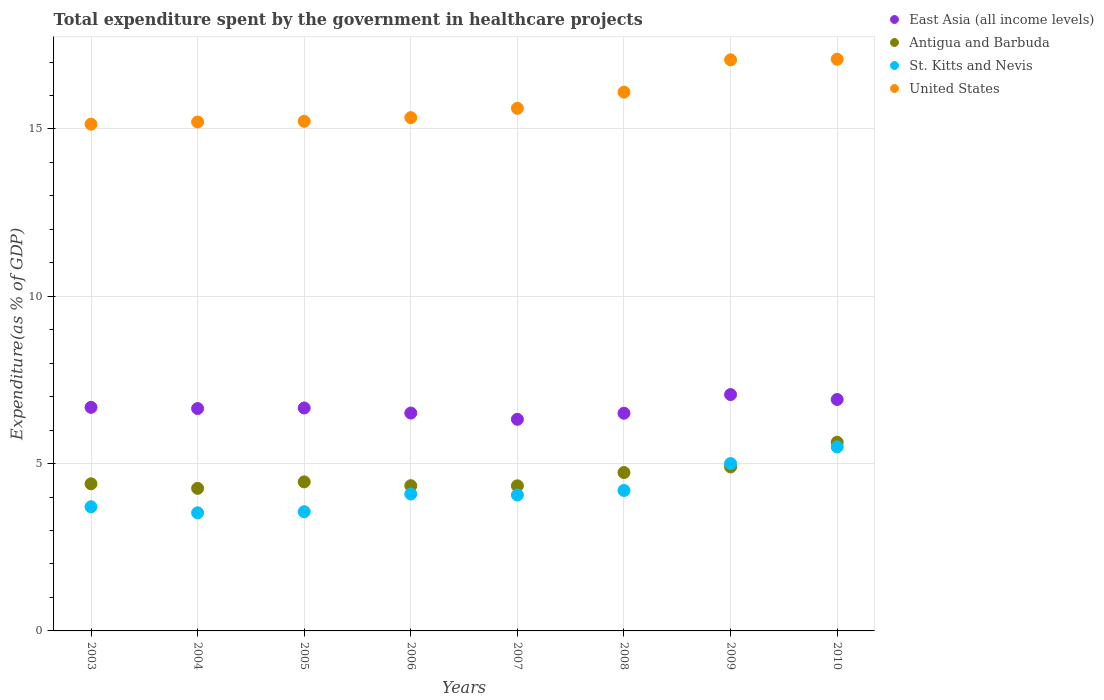How many different coloured dotlines are there?
Your answer should be compact. 4. Is the number of dotlines equal to the number of legend labels?
Give a very brief answer. Yes. What is the total expenditure spent by the government in healthcare projects in St. Kitts and Nevis in 2007?
Your response must be concise. 4.06. Across all years, what is the maximum total expenditure spent by the government in healthcare projects in Antigua and Barbuda?
Your answer should be compact. 5.64. Across all years, what is the minimum total expenditure spent by the government in healthcare projects in Antigua and Barbuda?
Ensure brevity in your answer.  4.26. In which year was the total expenditure spent by the government in healthcare projects in United States maximum?
Keep it short and to the point. 2010. In which year was the total expenditure spent by the government in healthcare projects in United States minimum?
Keep it short and to the point. 2003. What is the total total expenditure spent by the government in healthcare projects in Antigua and Barbuda in the graph?
Ensure brevity in your answer.  37.06. What is the difference between the total expenditure spent by the government in healthcare projects in St. Kitts and Nevis in 2009 and that in 2010?
Give a very brief answer. -0.5. What is the difference between the total expenditure spent by the government in healthcare projects in East Asia (all income levels) in 2003 and the total expenditure spent by the government in healthcare projects in United States in 2007?
Your answer should be compact. -8.94. What is the average total expenditure spent by the government in healthcare projects in Antigua and Barbuda per year?
Your response must be concise. 4.63. In the year 2010, what is the difference between the total expenditure spent by the government in healthcare projects in East Asia (all income levels) and total expenditure spent by the government in healthcare projects in St. Kitts and Nevis?
Ensure brevity in your answer.  1.42. In how many years, is the total expenditure spent by the government in healthcare projects in Antigua and Barbuda greater than 16 %?
Keep it short and to the point. 0. What is the ratio of the total expenditure spent by the government in healthcare projects in Antigua and Barbuda in 2004 to that in 2008?
Ensure brevity in your answer.  0.9. Is the total expenditure spent by the government in healthcare projects in St. Kitts and Nevis in 2003 less than that in 2010?
Your answer should be compact. Yes. What is the difference between the highest and the second highest total expenditure spent by the government in healthcare projects in St. Kitts and Nevis?
Make the answer very short. 0.5. What is the difference between the highest and the lowest total expenditure spent by the government in healthcare projects in St. Kitts and Nevis?
Provide a succinct answer. 1.97. Is the total expenditure spent by the government in healthcare projects in Antigua and Barbuda strictly greater than the total expenditure spent by the government in healthcare projects in United States over the years?
Your answer should be very brief. No. How many dotlines are there?
Your answer should be compact. 4. Are the values on the major ticks of Y-axis written in scientific E-notation?
Your response must be concise. No. How many legend labels are there?
Your answer should be very brief. 4. How are the legend labels stacked?
Offer a very short reply. Vertical. What is the title of the graph?
Offer a terse response. Total expenditure spent by the government in healthcare projects. What is the label or title of the X-axis?
Ensure brevity in your answer.  Years. What is the label or title of the Y-axis?
Your response must be concise. Expenditure(as % of GDP). What is the Expenditure(as % of GDP) of East Asia (all income levels) in 2003?
Keep it short and to the point. 6.68. What is the Expenditure(as % of GDP) of Antigua and Barbuda in 2003?
Provide a succinct answer. 4.4. What is the Expenditure(as % of GDP) in St. Kitts and Nevis in 2003?
Provide a short and direct response. 3.71. What is the Expenditure(as % of GDP) in United States in 2003?
Your answer should be compact. 15.14. What is the Expenditure(as % of GDP) in East Asia (all income levels) in 2004?
Your answer should be very brief. 6.65. What is the Expenditure(as % of GDP) of Antigua and Barbuda in 2004?
Offer a very short reply. 4.26. What is the Expenditure(as % of GDP) in St. Kitts and Nevis in 2004?
Offer a very short reply. 3.53. What is the Expenditure(as % of GDP) in United States in 2004?
Keep it short and to the point. 15.21. What is the Expenditure(as % of GDP) in East Asia (all income levels) in 2005?
Your response must be concise. 6.66. What is the Expenditure(as % of GDP) of Antigua and Barbuda in 2005?
Your answer should be compact. 4.45. What is the Expenditure(as % of GDP) of St. Kitts and Nevis in 2005?
Provide a short and direct response. 3.56. What is the Expenditure(as % of GDP) of United States in 2005?
Give a very brief answer. 15.23. What is the Expenditure(as % of GDP) in East Asia (all income levels) in 2006?
Offer a terse response. 6.51. What is the Expenditure(as % of GDP) of Antigua and Barbuda in 2006?
Offer a very short reply. 4.34. What is the Expenditure(as % of GDP) in St. Kitts and Nevis in 2006?
Ensure brevity in your answer.  4.09. What is the Expenditure(as % of GDP) of United States in 2006?
Make the answer very short. 15.34. What is the Expenditure(as % of GDP) of East Asia (all income levels) in 2007?
Make the answer very short. 6.32. What is the Expenditure(as % of GDP) in Antigua and Barbuda in 2007?
Give a very brief answer. 4.34. What is the Expenditure(as % of GDP) in St. Kitts and Nevis in 2007?
Give a very brief answer. 4.06. What is the Expenditure(as % of GDP) in United States in 2007?
Offer a terse response. 15.62. What is the Expenditure(as % of GDP) in East Asia (all income levels) in 2008?
Provide a succinct answer. 6.51. What is the Expenditure(as % of GDP) in Antigua and Barbuda in 2008?
Make the answer very short. 4.73. What is the Expenditure(as % of GDP) of St. Kitts and Nevis in 2008?
Your answer should be very brief. 4.2. What is the Expenditure(as % of GDP) of United States in 2008?
Keep it short and to the point. 16.1. What is the Expenditure(as % of GDP) in East Asia (all income levels) in 2009?
Make the answer very short. 7.06. What is the Expenditure(as % of GDP) of Antigua and Barbuda in 2009?
Keep it short and to the point. 4.9. What is the Expenditure(as % of GDP) of St. Kitts and Nevis in 2009?
Provide a short and direct response. 5. What is the Expenditure(as % of GDP) of United States in 2009?
Give a very brief answer. 17.07. What is the Expenditure(as % of GDP) in East Asia (all income levels) in 2010?
Your answer should be very brief. 6.92. What is the Expenditure(as % of GDP) in Antigua and Barbuda in 2010?
Offer a very short reply. 5.64. What is the Expenditure(as % of GDP) in St. Kitts and Nevis in 2010?
Provide a short and direct response. 5.5. What is the Expenditure(as % of GDP) of United States in 2010?
Make the answer very short. 17.08. Across all years, what is the maximum Expenditure(as % of GDP) in East Asia (all income levels)?
Provide a short and direct response. 7.06. Across all years, what is the maximum Expenditure(as % of GDP) in Antigua and Barbuda?
Keep it short and to the point. 5.64. Across all years, what is the maximum Expenditure(as % of GDP) in St. Kitts and Nevis?
Ensure brevity in your answer.  5.5. Across all years, what is the maximum Expenditure(as % of GDP) in United States?
Your answer should be compact. 17.08. Across all years, what is the minimum Expenditure(as % of GDP) of East Asia (all income levels)?
Offer a very short reply. 6.32. Across all years, what is the minimum Expenditure(as % of GDP) of Antigua and Barbuda?
Your response must be concise. 4.26. Across all years, what is the minimum Expenditure(as % of GDP) in St. Kitts and Nevis?
Provide a succinct answer. 3.53. Across all years, what is the minimum Expenditure(as % of GDP) in United States?
Your answer should be compact. 15.14. What is the total Expenditure(as % of GDP) in East Asia (all income levels) in the graph?
Offer a terse response. 53.31. What is the total Expenditure(as % of GDP) in Antigua and Barbuda in the graph?
Keep it short and to the point. 37.06. What is the total Expenditure(as % of GDP) of St. Kitts and Nevis in the graph?
Offer a terse response. 33.66. What is the total Expenditure(as % of GDP) of United States in the graph?
Give a very brief answer. 126.79. What is the difference between the Expenditure(as % of GDP) of East Asia (all income levels) in 2003 and that in 2004?
Offer a terse response. 0.04. What is the difference between the Expenditure(as % of GDP) in Antigua and Barbuda in 2003 and that in 2004?
Keep it short and to the point. 0.14. What is the difference between the Expenditure(as % of GDP) in St. Kitts and Nevis in 2003 and that in 2004?
Offer a terse response. 0.18. What is the difference between the Expenditure(as % of GDP) in United States in 2003 and that in 2004?
Your answer should be compact. -0.06. What is the difference between the Expenditure(as % of GDP) in East Asia (all income levels) in 2003 and that in 2005?
Give a very brief answer. 0.02. What is the difference between the Expenditure(as % of GDP) of Antigua and Barbuda in 2003 and that in 2005?
Your answer should be very brief. -0.06. What is the difference between the Expenditure(as % of GDP) in St. Kitts and Nevis in 2003 and that in 2005?
Your response must be concise. 0.15. What is the difference between the Expenditure(as % of GDP) of United States in 2003 and that in 2005?
Offer a terse response. -0.09. What is the difference between the Expenditure(as % of GDP) in East Asia (all income levels) in 2003 and that in 2006?
Your answer should be compact. 0.17. What is the difference between the Expenditure(as % of GDP) in Antigua and Barbuda in 2003 and that in 2006?
Your answer should be compact. 0.06. What is the difference between the Expenditure(as % of GDP) in St. Kitts and Nevis in 2003 and that in 2006?
Ensure brevity in your answer.  -0.38. What is the difference between the Expenditure(as % of GDP) of United States in 2003 and that in 2006?
Offer a very short reply. -0.19. What is the difference between the Expenditure(as % of GDP) in East Asia (all income levels) in 2003 and that in 2007?
Offer a terse response. 0.36. What is the difference between the Expenditure(as % of GDP) of Antigua and Barbuda in 2003 and that in 2007?
Give a very brief answer. 0.06. What is the difference between the Expenditure(as % of GDP) in St. Kitts and Nevis in 2003 and that in 2007?
Offer a very short reply. -0.35. What is the difference between the Expenditure(as % of GDP) in United States in 2003 and that in 2007?
Your answer should be compact. -0.47. What is the difference between the Expenditure(as % of GDP) in East Asia (all income levels) in 2003 and that in 2008?
Your answer should be compact. 0.18. What is the difference between the Expenditure(as % of GDP) of Antigua and Barbuda in 2003 and that in 2008?
Provide a succinct answer. -0.34. What is the difference between the Expenditure(as % of GDP) in St. Kitts and Nevis in 2003 and that in 2008?
Offer a terse response. -0.49. What is the difference between the Expenditure(as % of GDP) of United States in 2003 and that in 2008?
Make the answer very short. -0.96. What is the difference between the Expenditure(as % of GDP) in East Asia (all income levels) in 2003 and that in 2009?
Keep it short and to the point. -0.38. What is the difference between the Expenditure(as % of GDP) of Antigua and Barbuda in 2003 and that in 2009?
Offer a very short reply. -0.5. What is the difference between the Expenditure(as % of GDP) of St. Kitts and Nevis in 2003 and that in 2009?
Give a very brief answer. -1.29. What is the difference between the Expenditure(as % of GDP) of United States in 2003 and that in 2009?
Offer a very short reply. -1.92. What is the difference between the Expenditure(as % of GDP) of East Asia (all income levels) in 2003 and that in 2010?
Offer a terse response. -0.24. What is the difference between the Expenditure(as % of GDP) of Antigua and Barbuda in 2003 and that in 2010?
Provide a succinct answer. -1.24. What is the difference between the Expenditure(as % of GDP) of St. Kitts and Nevis in 2003 and that in 2010?
Offer a terse response. -1.79. What is the difference between the Expenditure(as % of GDP) of United States in 2003 and that in 2010?
Keep it short and to the point. -1.94. What is the difference between the Expenditure(as % of GDP) in East Asia (all income levels) in 2004 and that in 2005?
Your response must be concise. -0.02. What is the difference between the Expenditure(as % of GDP) of Antigua and Barbuda in 2004 and that in 2005?
Give a very brief answer. -0.19. What is the difference between the Expenditure(as % of GDP) of St. Kitts and Nevis in 2004 and that in 2005?
Keep it short and to the point. -0.03. What is the difference between the Expenditure(as % of GDP) in United States in 2004 and that in 2005?
Give a very brief answer. -0.02. What is the difference between the Expenditure(as % of GDP) in East Asia (all income levels) in 2004 and that in 2006?
Offer a terse response. 0.14. What is the difference between the Expenditure(as % of GDP) of Antigua and Barbuda in 2004 and that in 2006?
Your response must be concise. -0.08. What is the difference between the Expenditure(as % of GDP) of St. Kitts and Nevis in 2004 and that in 2006?
Provide a succinct answer. -0.56. What is the difference between the Expenditure(as % of GDP) of United States in 2004 and that in 2006?
Keep it short and to the point. -0.13. What is the difference between the Expenditure(as % of GDP) of East Asia (all income levels) in 2004 and that in 2007?
Your answer should be very brief. 0.32. What is the difference between the Expenditure(as % of GDP) in Antigua and Barbuda in 2004 and that in 2007?
Offer a terse response. -0.08. What is the difference between the Expenditure(as % of GDP) of St. Kitts and Nevis in 2004 and that in 2007?
Provide a short and direct response. -0.53. What is the difference between the Expenditure(as % of GDP) of United States in 2004 and that in 2007?
Ensure brevity in your answer.  -0.41. What is the difference between the Expenditure(as % of GDP) of East Asia (all income levels) in 2004 and that in 2008?
Give a very brief answer. 0.14. What is the difference between the Expenditure(as % of GDP) of Antigua and Barbuda in 2004 and that in 2008?
Keep it short and to the point. -0.47. What is the difference between the Expenditure(as % of GDP) in St. Kitts and Nevis in 2004 and that in 2008?
Your answer should be very brief. -0.67. What is the difference between the Expenditure(as % of GDP) in United States in 2004 and that in 2008?
Your answer should be compact. -0.89. What is the difference between the Expenditure(as % of GDP) in East Asia (all income levels) in 2004 and that in 2009?
Give a very brief answer. -0.42. What is the difference between the Expenditure(as % of GDP) in Antigua and Barbuda in 2004 and that in 2009?
Ensure brevity in your answer.  -0.64. What is the difference between the Expenditure(as % of GDP) of St. Kitts and Nevis in 2004 and that in 2009?
Offer a very short reply. -1.47. What is the difference between the Expenditure(as % of GDP) of United States in 2004 and that in 2009?
Your response must be concise. -1.86. What is the difference between the Expenditure(as % of GDP) of East Asia (all income levels) in 2004 and that in 2010?
Ensure brevity in your answer.  -0.27. What is the difference between the Expenditure(as % of GDP) of Antigua and Barbuda in 2004 and that in 2010?
Keep it short and to the point. -1.38. What is the difference between the Expenditure(as % of GDP) of St. Kitts and Nevis in 2004 and that in 2010?
Provide a succinct answer. -1.97. What is the difference between the Expenditure(as % of GDP) of United States in 2004 and that in 2010?
Offer a terse response. -1.87. What is the difference between the Expenditure(as % of GDP) of East Asia (all income levels) in 2005 and that in 2006?
Your answer should be compact. 0.15. What is the difference between the Expenditure(as % of GDP) in Antigua and Barbuda in 2005 and that in 2006?
Offer a terse response. 0.11. What is the difference between the Expenditure(as % of GDP) in St. Kitts and Nevis in 2005 and that in 2006?
Make the answer very short. -0.53. What is the difference between the Expenditure(as % of GDP) of United States in 2005 and that in 2006?
Give a very brief answer. -0.11. What is the difference between the Expenditure(as % of GDP) of East Asia (all income levels) in 2005 and that in 2007?
Offer a terse response. 0.34. What is the difference between the Expenditure(as % of GDP) of Antigua and Barbuda in 2005 and that in 2007?
Offer a terse response. 0.12. What is the difference between the Expenditure(as % of GDP) in St. Kitts and Nevis in 2005 and that in 2007?
Your answer should be very brief. -0.5. What is the difference between the Expenditure(as % of GDP) in United States in 2005 and that in 2007?
Offer a very short reply. -0.39. What is the difference between the Expenditure(as % of GDP) in East Asia (all income levels) in 2005 and that in 2008?
Offer a terse response. 0.16. What is the difference between the Expenditure(as % of GDP) of Antigua and Barbuda in 2005 and that in 2008?
Provide a short and direct response. -0.28. What is the difference between the Expenditure(as % of GDP) in St. Kitts and Nevis in 2005 and that in 2008?
Offer a very short reply. -0.64. What is the difference between the Expenditure(as % of GDP) in United States in 2005 and that in 2008?
Your answer should be compact. -0.87. What is the difference between the Expenditure(as % of GDP) of East Asia (all income levels) in 2005 and that in 2009?
Your answer should be compact. -0.4. What is the difference between the Expenditure(as % of GDP) in Antigua and Barbuda in 2005 and that in 2009?
Provide a succinct answer. -0.45. What is the difference between the Expenditure(as % of GDP) of St. Kitts and Nevis in 2005 and that in 2009?
Give a very brief answer. -1.44. What is the difference between the Expenditure(as % of GDP) in United States in 2005 and that in 2009?
Offer a terse response. -1.84. What is the difference between the Expenditure(as % of GDP) of East Asia (all income levels) in 2005 and that in 2010?
Provide a succinct answer. -0.25. What is the difference between the Expenditure(as % of GDP) in Antigua and Barbuda in 2005 and that in 2010?
Ensure brevity in your answer.  -1.18. What is the difference between the Expenditure(as % of GDP) of St. Kitts and Nevis in 2005 and that in 2010?
Give a very brief answer. -1.94. What is the difference between the Expenditure(as % of GDP) of United States in 2005 and that in 2010?
Keep it short and to the point. -1.85. What is the difference between the Expenditure(as % of GDP) in East Asia (all income levels) in 2006 and that in 2007?
Ensure brevity in your answer.  0.19. What is the difference between the Expenditure(as % of GDP) of Antigua and Barbuda in 2006 and that in 2007?
Make the answer very short. 0. What is the difference between the Expenditure(as % of GDP) of St. Kitts and Nevis in 2006 and that in 2007?
Your response must be concise. 0.03. What is the difference between the Expenditure(as % of GDP) in United States in 2006 and that in 2007?
Provide a short and direct response. -0.28. What is the difference between the Expenditure(as % of GDP) in East Asia (all income levels) in 2006 and that in 2008?
Provide a succinct answer. 0.01. What is the difference between the Expenditure(as % of GDP) of Antigua and Barbuda in 2006 and that in 2008?
Keep it short and to the point. -0.39. What is the difference between the Expenditure(as % of GDP) of St. Kitts and Nevis in 2006 and that in 2008?
Your answer should be very brief. -0.11. What is the difference between the Expenditure(as % of GDP) of United States in 2006 and that in 2008?
Give a very brief answer. -0.76. What is the difference between the Expenditure(as % of GDP) of East Asia (all income levels) in 2006 and that in 2009?
Your answer should be very brief. -0.55. What is the difference between the Expenditure(as % of GDP) in Antigua and Barbuda in 2006 and that in 2009?
Make the answer very short. -0.56. What is the difference between the Expenditure(as % of GDP) in St. Kitts and Nevis in 2006 and that in 2009?
Make the answer very short. -0.91. What is the difference between the Expenditure(as % of GDP) of United States in 2006 and that in 2009?
Keep it short and to the point. -1.73. What is the difference between the Expenditure(as % of GDP) in East Asia (all income levels) in 2006 and that in 2010?
Your answer should be compact. -0.41. What is the difference between the Expenditure(as % of GDP) in Antigua and Barbuda in 2006 and that in 2010?
Give a very brief answer. -1.3. What is the difference between the Expenditure(as % of GDP) of St. Kitts and Nevis in 2006 and that in 2010?
Provide a short and direct response. -1.41. What is the difference between the Expenditure(as % of GDP) in United States in 2006 and that in 2010?
Make the answer very short. -1.74. What is the difference between the Expenditure(as % of GDP) in East Asia (all income levels) in 2007 and that in 2008?
Make the answer very short. -0.18. What is the difference between the Expenditure(as % of GDP) in Antigua and Barbuda in 2007 and that in 2008?
Give a very brief answer. -0.4. What is the difference between the Expenditure(as % of GDP) of St. Kitts and Nevis in 2007 and that in 2008?
Provide a short and direct response. -0.13. What is the difference between the Expenditure(as % of GDP) in United States in 2007 and that in 2008?
Keep it short and to the point. -0.48. What is the difference between the Expenditure(as % of GDP) in East Asia (all income levels) in 2007 and that in 2009?
Your response must be concise. -0.74. What is the difference between the Expenditure(as % of GDP) in Antigua and Barbuda in 2007 and that in 2009?
Your answer should be compact. -0.56. What is the difference between the Expenditure(as % of GDP) of St. Kitts and Nevis in 2007 and that in 2009?
Your answer should be very brief. -0.94. What is the difference between the Expenditure(as % of GDP) in United States in 2007 and that in 2009?
Offer a very short reply. -1.45. What is the difference between the Expenditure(as % of GDP) of East Asia (all income levels) in 2007 and that in 2010?
Provide a succinct answer. -0.59. What is the difference between the Expenditure(as % of GDP) in Antigua and Barbuda in 2007 and that in 2010?
Offer a very short reply. -1.3. What is the difference between the Expenditure(as % of GDP) of St. Kitts and Nevis in 2007 and that in 2010?
Keep it short and to the point. -1.44. What is the difference between the Expenditure(as % of GDP) of United States in 2007 and that in 2010?
Your answer should be compact. -1.47. What is the difference between the Expenditure(as % of GDP) of East Asia (all income levels) in 2008 and that in 2009?
Your response must be concise. -0.56. What is the difference between the Expenditure(as % of GDP) of Antigua and Barbuda in 2008 and that in 2009?
Your response must be concise. -0.17. What is the difference between the Expenditure(as % of GDP) in St. Kitts and Nevis in 2008 and that in 2009?
Give a very brief answer. -0.8. What is the difference between the Expenditure(as % of GDP) of United States in 2008 and that in 2009?
Your response must be concise. -0.97. What is the difference between the Expenditure(as % of GDP) in East Asia (all income levels) in 2008 and that in 2010?
Your answer should be compact. -0.41. What is the difference between the Expenditure(as % of GDP) in Antigua and Barbuda in 2008 and that in 2010?
Make the answer very short. -0.9. What is the difference between the Expenditure(as % of GDP) in St. Kitts and Nevis in 2008 and that in 2010?
Provide a short and direct response. -1.3. What is the difference between the Expenditure(as % of GDP) in United States in 2008 and that in 2010?
Your answer should be very brief. -0.98. What is the difference between the Expenditure(as % of GDP) in East Asia (all income levels) in 2009 and that in 2010?
Make the answer very short. 0.15. What is the difference between the Expenditure(as % of GDP) of Antigua and Barbuda in 2009 and that in 2010?
Provide a short and direct response. -0.74. What is the difference between the Expenditure(as % of GDP) in St. Kitts and Nevis in 2009 and that in 2010?
Offer a terse response. -0.5. What is the difference between the Expenditure(as % of GDP) in United States in 2009 and that in 2010?
Your response must be concise. -0.02. What is the difference between the Expenditure(as % of GDP) in East Asia (all income levels) in 2003 and the Expenditure(as % of GDP) in Antigua and Barbuda in 2004?
Make the answer very short. 2.42. What is the difference between the Expenditure(as % of GDP) in East Asia (all income levels) in 2003 and the Expenditure(as % of GDP) in St. Kitts and Nevis in 2004?
Offer a very short reply. 3.15. What is the difference between the Expenditure(as % of GDP) in East Asia (all income levels) in 2003 and the Expenditure(as % of GDP) in United States in 2004?
Offer a very short reply. -8.53. What is the difference between the Expenditure(as % of GDP) in Antigua and Barbuda in 2003 and the Expenditure(as % of GDP) in St. Kitts and Nevis in 2004?
Keep it short and to the point. 0.87. What is the difference between the Expenditure(as % of GDP) of Antigua and Barbuda in 2003 and the Expenditure(as % of GDP) of United States in 2004?
Make the answer very short. -10.81. What is the difference between the Expenditure(as % of GDP) of St. Kitts and Nevis in 2003 and the Expenditure(as % of GDP) of United States in 2004?
Give a very brief answer. -11.5. What is the difference between the Expenditure(as % of GDP) of East Asia (all income levels) in 2003 and the Expenditure(as % of GDP) of Antigua and Barbuda in 2005?
Make the answer very short. 2.23. What is the difference between the Expenditure(as % of GDP) of East Asia (all income levels) in 2003 and the Expenditure(as % of GDP) of St. Kitts and Nevis in 2005?
Provide a short and direct response. 3.12. What is the difference between the Expenditure(as % of GDP) of East Asia (all income levels) in 2003 and the Expenditure(as % of GDP) of United States in 2005?
Your answer should be very brief. -8.55. What is the difference between the Expenditure(as % of GDP) in Antigua and Barbuda in 2003 and the Expenditure(as % of GDP) in St. Kitts and Nevis in 2005?
Keep it short and to the point. 0.83. What is the difference between the Expenditure(as % of GDP) in Antigua and Barbuda in 2003 and the Expenditure(as % of GDP) in United States in 2005?
Offer a very short reply. -10.83. What is the difference between the Expenditure(as % of GDP) of St. Kitts and Nevis in 2003 and the Expenditure(as % of GDP) of United States in 2005?
Your answer should be compact. -11.52. What is the difference between the Expenditure(as % of GDP) of East Asia (all income levels) in 2003 and the Expenditure(as % of GDP) of Antigua and Barbuda in 2006?
Your answer should be compact. 2.34. What is the difference between the Expenditure(as % of GDP) of East Asia (all income levels) in 2003 and the Expenditure(as % of GDP) of St. Kitts and Nevis in 2006?
Your answer should be compact. 2.59. What is the difference between the Expenditure(as % of GDP) of East Asia (all income levels) in 2003 and the Expenditure(as % of GDP) of United States in 2006?
Your answer should be compact. -8.66. What is the difference between the Expenditure(as % of GDP) of Antigua and Barbuda in 2003 and the Expenditure(as % of GDP) of St. Kitts and Nevis in 2006?
Offer a terse response. 0.31. What is the difference between the Expenditure(as % of GDP) in Antigua and Barbuda in 2003 and the Expenditure(as % of GDP) in United States in 2006?
Give a very brief answer. -10.94. What is the difference between the Expenditure(as % of GDP) in St. Kitts and Nevis in 2003 and the Expenditure(as % of GDP) in United States in 2006?
Make the answer very short. -11.63. What is the difference between the Expenditure(as % of GDP) of East Asia (all income levels) in 2003 and the Expenditure(as % of GDP) of Antigua and Barbuda in 2007?
Keep it short and to the point. 2.34. What is the difference between the Expenditure(as % of GDP) of East Asia (all income levels) in 2003 and the Expenditure(as % of GDP) of St. Kitts and Nevis in 2007?
Give a very brief answer. 2.62. What is the difference between the Expenditure(as % of GDP) in East Asia (all income levels) in 2003 and the Expenditure(as % of GDP) in United States in 2007?
Ensure brevity in your answer.  -8.94. What is the difference between the Expenditure(as % of GDP) of Antigua and Barbuda in 2003 and the Expenditure(as % of GDP) of St. Kitts and Nevis in 2007?
Provide a succinct answer. 0.33. What is the difference between the Expenditure(as % of GDP) of Antigua and Barbuda in 2003 and the Expenditure(as % of GDP) of United States in 2007?
Your answer should be very brief. -11.22. What is the difference between the Expenditure(as % of GDP) in St. Kitts and Nevis in 2003 and the Expenditure(as % of GDP) in United States in 2007?
Ensure brevity in your answer.  -11.91. What is the difference between the Expenditure(as % of GDP) in East Asia (all income levels) in 2003 and the Expenditure(as % of GDP) in Antigua and Barbuda in 2008?
Your response must be concise. 1.95. What is the difference between the Expenditure(as % of GDP) of East Asia (all income levels) in 2003 and the Expenditure(as % of GDP) of St. Kitts and Nevis in 2008?
Ensure brevity in your answer.  2.48. What is the difference between the Expenditure(as % of GDP) in East Asia (all income levels) in 2003 and the Expenditure(as % of GDP) in United States in 2008?
Ensure brevity in your answer.  -9.42. What is the difference between the Expenditure(as % of GDP) of Antigua and Barbuda in 2003 and the Expenditure(as % of GDP) of St. Kitts and Nevis in 2008?
Ensure brevity in your answer.  0.2. What is the difference between the Expenditure(as % of GDP) in Antigua and Barbuda in 2003 and the Expenditure(as % of GDP) in United States in 2008?
Your answer should be compact. -11.7. What is the difference between the Expenditure(as % of GDP) of St. Kitts and Nevis in 2003 and the Expenditure(as % of GDP) of United States in 2008?
Your answer should be very brief. -12.39. What is the difference between the Expenditure(as % of GDP) in East Asia (all income levels) in 2003 and the Expenditure(as % of GDP) in Antigua and Barbuda in 2009?
Give a very brief answer. 1.78. What is the difference between the Expenditure(as % of GDP) in East Asia (all income levels) in 2003 and the Expenditure(as % of GDP) in St. Kitts and Nevis in 2009?
Ensure brevity in your answer.  1.68. What is the difference between the Expenditure(as % of GDP) in East Asia (all income levels) in 2003 and the Expenditure(as % of GDP) in United States in 2009?
Your response must be concise. -10.39. What is the difference between the Expenditure(as % of GDP) of Antigua and Barbuda in 2003 and the Expenditure(as % of GDP) of St. Kitts and Nevis in 2009?
Provide a succinct answer. -0.61. What is the difference between the Expenditure(as % of GDP) of Antigua and Barbuda in 2003 and the Expenditure(as % of GDP) of United States in 2009?
Your answer should be very brief. -12.67. What is the difference between the Expenditure(as % of GDP) of St. Kitts and Nevis in 2003 and the Expenditure(as % of GDP) of United States in 2009?
Make the answer very short. -13.36. What is the difference between the Expenditure(as % of GDP) of East Asia (all income levels) in 2003 and the Expenditure(as % of GDP) of Antigua and Barbuda in 2010?
Keep it short and to the point. 1.04. What is the difference between the Expenditure(as % of GDP) in East Asia (all income levels) in 2003 and the Expenditure(as % of GDP) in St. Kitts and Nevis in 2010?
Make the answer very short. 1.18. What is the difference between the Expenditure(as % of GDP) in East Asia (all income levels) in 2003 and the Expenditure(as % of GDP) in United States in 2010?
Offer a terse response. -10.4. What is the difference between the Expenditure(as % of GDP) in Antigua and Barbuda in 2003 and the Expenditure(as % of GDP) in St. Kitts and Nevis in 2010?
Provide a short and direct response. -1.1. What is the difference between the Expenditure(as % of GDP) in Antigua and Barbuda in 2003 and the Expenditure(as % of GDP) in United States in 2010?
Your answer should be compact. -12.69. What is the difference between the Expenditure(as % of GDP) of St. Kitts and Nevis in 2003 and the Expenditure(as % of GDP) of United States in 2010?
Give a very brief answer. -13.37. What is the difference between the Expenditure(as % of GDP) in East Asia (all income levels) in 2004 and the Expenditure(as % of GDP) in Antigua and Barbuda in 2005?
Offer a terse response. 2.19. What is the difference between the Expenditure(as % of GDP) of East Asia (all income levels) in 2004 and the Expenditure(as % of GDP) of St. Kitts and Nevis in 2005?
Your answer should be very brief. 3.08. What is the difference between the Expenditure(as % of GDP) of East Asia (all income levels) in 2004 and the Expenditure(as % of GDP) of United States in 2005?
Give a very brief answer. -8.58. What is the difference between the Expenditure(as % of GDP) in Antigua and Barbuda in 2004 and the Expenditure(as % of GDP) in St. Kitts and Nevis in 2005?
Give a very brief answer. 0.7. What is the difference between the Expenditure(as % of GDP) in Antigua and Barbuda in 2004 and the Expenditure(as % of GDP) in United States in 2005?
Ensure brevity in your answer.  -10.97. What is the difference between the Expenditure(as % of GDP) of St. Kitts and Nevis in 2004 and the Expenditure(as % of GDP) of United States in 2005?
Provide a short and direct response. -11.7. What is the difference between the Expenditure(as % of GDP) in East Asia (all income levels) in 2004 and the Expenditure(as % of GDP) in Antigua and Barbuda in 2006?
Give a very brief answer. 2.31. What is the difference between the Expenditure(as % of GDP) of East Asia (all income levels) in 2004 and the Expenditure(as % of GDP) of St. Kitts and Nevis in 2006?
Offer a terse response. 2.56. What is the difference between the Expenditure(as % of GDP) in East Asia (all income levels) in 2004 and the Expenditure(as % of GDP) in United States in 2006?
Give a very brief answer. -8.69. What is the difference between the Expenditure(as % of GDP) of Antigua and Barbuda in 2004 and the Expenditure(as % of GDP) of St. Kitts and Nevis in 2006?
Offer a terse response. 0.17. What is the difference between the Expenditure(as % of GDP) in Antigua and Barbuda in 2004 and the Expenditure(as % of GDP) in United States in 2006?
Your answer should be very brief. -11.08. What is the difference between the Expenditure(as % of GDP) in St. Kitts and Nevis in 2004 and the Expenditure(as % of GDP) in United States in 2006?
Make the answer very short. -11.81. What is the difference between the Expenditure(as % of GDP) in East Asia (all income levels) in 2004 and the Expenditure(as % of GDP) in Antigua and Barbuda in 2007?
Your answer should be very brief. 2.31. What is the difference between the Expenditure(as % of GDP) in East Asia (all income levels) in 2004 and the Expenditure(as % of GDP) in St. Kitts and Nevis in 2007?
Your answer should be very brief. 2.58. What is the difference between the Expenditure(as % of GDP) of East Asia (all income levels) in 2004 and the Expenditure(as % of GDP) of United States in 2007?
Provide a succinct answer. -8.97. What is the difference between the Expenditure(as % of GDP) in Antigua and Barbuda in 2004 and the Expenditure(as % of GDP) in St. Kitts and Nevis in 2007?
Keep it short and to the point. 0.2. What is the difference between the Expenditure(as % of GDP) of Antigua and Barbuda in 2004 and the Expenditure(as % of GDP) of United States in 2007?
Keep it short and to the point. -11.36. What is the difference between the Expenditure(as % of GDP) in St. Kitts and Nevis in 2004 and the Expenditure(as % of GDP) in United States in 2007?
Your response must be concise. -12.09. What is the difference between the Expenditure(as % of GDP) in East Asia (all income levels) in 2004 and the Expenditure(as % of GDP) in Antigua and Barbuda in 2008?
Give a very brief answer. 1.91. What is the difference between the Expenditure(as % of GDP) in East Asia (all income levels) in 2004 and the Expenditure(as % of GDP) in St. Kitts and Nevis in 2008?
Offer a terse response. 2.45. What is the difference between the Expenditure(as % of GDP) of East Asia (all income levels) in 2004 and the Expenditure(as % of GDP) of United States in 2008?
Ensure brevity in your answer.  -9.46. What is the difference between the Expenditure(as % of GDP) in Antigua and Barbuda in 2004 and the Expenditure(as % of GDP) in St. Kitts and Nevis in 2008?
Ensure brevity in your answer.  0.06. What is the difference between the Expenditure(as % of GDP) of Antigua and Barbuda in 2004 and the Expenditure(as % of GDP) of United States in 2008?
Your response must be concise. -11.84. What is the difference between the Expenditure(as % of GDP) in St. Kitts and Nevis in 2004 and the Expenditure(as % of GDP) in United States in 2008?
Your answer should be compact. -12.57. What is the difference between the Expenditure(as % of GDP) of East Asia (all income levels) in 2004 and the Expenditure(as % of GDP) of Antigua and Barbuda in 2009?
Offer a terse response. 1.74. What is the difference between the Expenditure(as % of GDP) of East Asia (all income levels) in 2004 and the Expenditure(as % of GDP) of St. Kitts and Nevis in 2009?
Offer a terse response. 1.64. What is the difference between the Expenditure(as % of GDP) in East Asia (all income levels) in 2004 and the Expenditure(as % of GDP) in United States in 2009?
Provide a succinct answer. -10.42. What is the difference between the Expenditure(as % of GDP) of Antigua and Barbuda in 2004 and the Expenditure(as % of GDP) of St. Kitts and Nevis in 2009?
Offer a very short reply. -0.74. What is the difference between the Expenditure(as % of GDP) in Antigua and Barbuda in 2004 and the Expenditure(as % of GDP) in United States in 2009?
Give a very brief answer. -12.81. What is the difference between the Expenditure(as % of GDP) in St. Kitts and Nevis in 2004 and the Expenditure(as % of GDP) in United States in 2009?
Offer a terse response. -13.54. What is the difference between the Expenditure(as % of GDP) of East Asia (all income levels) in 2004 and the Expenditure(as % of GDP) of Antigua and Barbuda in 2010?
Offer a terse response. 1.01. What is the difference between the Expenditure(as % of GDP) of East Asia (all income levels) in 2004 and the Expenditure(as % of GDP) of St. Kitts and Nevis in 2010?
Give a very brief answer. 1.15. What is the difference between the Expenditure(as % of GDP) of East Asia (all income levels) in 2004 and the Expenditure(as % of GDP) of United States in 2010?
Provide a short and direct response. -10.44. What is the difference between the Expenditure(as % of GDP) of Antigua and Barbuda in 2004 and the Expenditure(as % of GDP) of St. Kitts and Nevis in 2010?
Make the answer very short. -1.24. What is the difference between the Expenditure(as % of GDP) in Antigua and Barbuda in 2004 and the Expenditure(as % of GDP) in United States in 2010?
Keep it short and to the point. -12.82. What is the difference between the Expenditure(as % of GDP) in St. Kitts and Nevis in 2004 and the Expenditure(as % of GDP) in United States in 2010?
Offer a very short reply. -13.55. What is the difference between the Expenditure(as % of GDP) in East Asia (all income levels) in 2005 and the Expenditure(as % of GDP) in Antigua and Barbuda in 2006?
Your response must be concise. 2.32. What is the difference between the Expenditure(as % of GDP) of East Asia (all income levels) in 2005 and the Expenditure(as % of GDP) of St. Kitts and Nevis in 2006?
Offer a very short reply. 2.57. What is the difference between the Expenditure(as % of GDP) in East Asia (all income levels) in 2005 and the Expenditure(as % of GDP) in United States in 2006?
Your response must be concise. -8.68. What is the difference between the Expenditure(as % of GDP) of Antigua and Barbuda in 2005 and the Expenditure(as % of GDP) of St. Kitts and Nevis in 2006?
Offer a very short reply. 0.36. What is the difference between the Expenditure(as % of GDP) of Antigua and Barbuda in 2005 and the Expenditure(as % of GDP) of United States in 2006?
Make the answer very short. -10.89. What is the difference between the Expenditure(as % of GDP) in St. Kitts and Nevis in 2005 and the Expenditure(as % of GDP) in United States in 2006?
Make the answer very short. -11.78. What is the difference between the Expenditure(as % of GDP) in East Asia (all income levels) in 2005 and the Expenditure(as % of GDP) in Antigua and Barbuda in 2007?
Ensure brevity in your answer.  2.33. What is the difference between the Expenditure(as % of GDP) in East Asia (all income levels) in 2005 and the Expenditure(as % of GDP) in St. Kitts and Nevis in 2007?
Make the answer very short. 2.6. What is the difference between the Expenditure(as % of GDP) of East Asia (all income levels) in 2005 and the Expenditure(as % of GDP) of United States in 2007?
Keep it short and to the point. -8.96. What is the difference between the Expenditure(as % of GDP) of Antigua and Barbuda in 2005 and the Expenditure(as % of GDP) of St. Kitts and Nevis in 2007?
Ensure brevity in your answer.  0.39. What is the difference between the Expenditure(as % of GDP) in Antigua and Barbuda in 2005 and the Expenditure(as % of GDP) in United States in 2007?
Your response must be concise. -11.16. What is the difference between the Expenditure(as % of GDP) of St. Kitts and Nevis in 2005 and the Expenditure(as % of GDP) of United States in 2007?
Give a very brief answer. -12.06. What is the difference between the Expenditure(as % of GDP) in East Asia (all income levels) in 2005 and the Expenditure(as % of GDP) in Antigua and Barbuda in 2008?
Keep it short and to the point. 1.93. What is the difference between the Expenditure(as % of GDP) of East Asia (all income levels) in 2005 and the Expenditure(as % of GDP) of St. Kitts and Nevis in 2008?
Offer a terse response. 2.46. What is the difference between the Expenditure(as % of GDP) of East Asia (all income levels) in 2005 and the Expenditure(as % of GDP) of United States in 2008?
Ensure brevity in your answer.  -9.44. What is the difference between the Expenditure(as % of GDP) in Antigua and Barbuda in 2005 and the Expenditure(as % of GDP) in St. Kitts and Nevis in 2008?
Provide a succinct answer. 0.26. What is the difference between the Expenditure(as % of GDP) in Antigua and Barbuda in 2005 and the Expenditure(as % of GDP) in United States in 2008?
Provide a succinct answer. -11.65. What is the difference between the Expenditure(as % of GDP) of St. Kitts and Nevis in 2005 and the Expenditure(as % of GDP) of United States in 2008?
Keep it short and to the point. -12.54. What is the difference between the Expenditure(as % of GDP) of East Asia (all income levels) in 2005 and the Expenditure(as % of GDP) of Antigua and Barbuda in 2009?
Make the answer very short. 1.76. What is the difference between the Expenditure(as % of GDP) of East Asia (all income levels) in 2005 and the Expenditure(as % of GDP) of St. Kitts and Nevis in 2009?
Keep it short and to the point. 1.66. What is the difference between the Expenditure(as % of GDP) of East Asia (all income levels) in 2005 and the Expenditure(as % of GDP) of United States in 2009?
Your answer should be compact. -10.4. What is the difference between the Expenditure(as % of GDP) in Antigua and Barbuda in 2005 and the Expenditure(as % of GDP) in St. Kitts and Nevis in 2009?
Provide a short and direct response. -0.55. What is the difference between the Expenditure(as % of GDP) in Antigua and Barbuda in 2005 and the Expenditure(as % of GDP) in United States in 2009?
Your answer should be very brief. -12.61. What is the difference between the Expenditure(as % of GDP) in St. Kitts and Nevis in 2005 and the Expenditure(as % of GDP) in United States in 2009?
Make the answer very short. -13.5. What is the difference between the Expenditure(as % of GDP) of East Asia (all income levels) in 2005 and the Expenditure(as % of GDP) of Antigua and Barbuda in 2010?
Provide a succinct answer. 1.03. What is the difference between the Expenditure(as % of GDP) of East Asia (all income levels) in 2005 and the Expenditure(as % of GDP) of St. Kitts and Nevis in 2010?
Your response must be concise. 1.16. What is the difference between the Expenditure(as % of GDP) of East Asia (all income levels) in 2005 and the Expenditure(as % of GDP) of United States in 2010?
Your answer should be compact. -10.42. What is the difference between the Expenditure(as % of GDP) of Antigua and Barbuda in 2005 and the Expenditure(as % of GDP) of St. Kitts and Nevis in 2010?
Give a very brief answer. -1.05. What is the difference between the Expenditure(as % of GDP) in Antigua and Barbuda in 2005 and the Expenditure(as % of GDP) in United States in 2010?
Ensure brevity in your answer.  -12.63. What is the difference between the Expenditure(as % of GDP) of St. Kitts and Nevis in 2005 and the Expenditure(as % of GDP) of United States in 2010?
Give a very brief answer. -13.52. What is the difference between the Expenditure(as % of GDP) in East Asia (all income levels) in 2006 and the Expenditure(as % of GDP) in Antigua and Barbuda in 2007?
Provide a succinct answer. 2.17. What is the difference between the Expenditure(as % of GDP) of East Asia (all income levels) in 2006 and the Expenditure(as % of GDP) of St. Kitts and Nevis in 2007?
Offer a terse response. 2.45. What is the difference between the Expenditure(as % of GDP) of East Asia (all income levels) in 2006 and the Expenditure(as % of GDP) of United States in 2007?
Your answer should be compact. -9.11. What is the difference between the Expenditure(as % of GDP) of Antigua and Barbuda in 2006 and the Expenditure(as % of GDP) of St. Kitts and Nevis in 2007?
Ensure brevity in your answer.  0.28. What is the difference between the Expenditure(as % of GDP) in Antigua and Barbuda in 2006 and the Expenditure(as % of GDP) in United States in 2007?
Keep it short and to the point. -11.28. What is the difference between the Expenditure(as % of GDP) of St. Kitts and Nevis in 2006 and the Expenditure(as % of GDP) of United States in 2007?
Offer a very short reply. -11.53. What is the difference between the Expenditure(as % of GDP) of East Asia (all income levels) in 2006 and the Expenditure(as % of GDP) of Antigua and Barbuda in 2008?
Keep it short and to the point. 1.78. What is the difference between the Expenditure(as % of GDP) in East Asia (all income levels) in 2006 and the Expenditure(as % of GDP) in St. Kitts and Nevis in 2008?
Keep it short and to the point. 2.31. What is the difference between the Expenditure(as % of GDP) in East Asia (all income levels) in 2006 and the Expenditure(as % of GDP) in United States in 2008?
Offer a terse response. -9.59. What is the difference between the Expenditure(as % of GDP) of Antigua and Barbuda in 2006 and the Expenditure(as % of GDP) of St. Kitts and Nevis in 2008?
Your response must be concise. 0.14. What is the difference between the Expenditure(as % of GDP) of Antigua and Barbuda in 2006 and the Expenditure(as % of GDP) of United States in 2008?
Your response must be concise. -11.76. What is the difference between the Expenditure(as % of GDP) of St. Kitts and Nevis in 2006 and the Expenditure(as % of GDP) of United States in 2008?
Provide a succinct answer. -12.01. What is the difference between the Expenditure(as % of GDP) of East Asia (all income levels) in 2006 and the Expenditure(as % of GDP) of Antigua and Barbuda in 2009?
Your response must be concise. 1.61. What is the difference between the Expenditure(as % of GDP) in East Asia (all income levels) in 2006 and the Expenditure(as % of GDP) in St. Kitts and Nevis in 2009?
Provide a succinct answer. 1.51. What is the difference between the Expenditure(as % of GDP) of East Asia (all income levels) in 2006 and the Expenditure(as % of GDP) of United States in 2009?
Give a very brief answer. -10.56. What is the difference between the Expenditure(as % of GDP) of Antigua and Barbuda in 2006 and the Expenditure(as % of GDP) of St. Kitts and Nevis in 2009?
Provide a short and direct response. -0.66. What is the difference between the Expenditure(as % of GDP) in Antigua and Barbuda in 2006 and the Expenditure(as % of GDP) in United States in 2009?
Your response must be concise. -12.73. What is the difference between the Expenditure(as % of GDP) in St. Kitts and Nevis in 2006 and the Expenditure(as % of GDP) in United States in 2009?
Provide a succinct answer. -12.98. What is the difference between the Expenditure(as % of GDP) of East Asia (all income levels) in 2006 and the Expenditure(as % of GDP) of Antigua and Barbuda in 2010?
Offer a very short reply. 0.87. What is the difference between the Expenditure(as % of GDP) of East Asia (all income levels) in 2006 and the Expenditure(as % of GDP) of St. Kitts and Nevis in 2010?
Your answer should be very brief. 1.01. What is the difference between the Expenditure(as % of GDP) in East Asia (all income levels) in 2006 and the Expenditure(as % of GDP) in United States in 2010?
Ensure brevity in your answer.  -10.57. What is the difference between the Expenditure(as % of GDP) of Antigua and Barbuda in 2006 and the Expenditure(as % of GDP) of St. Kitts and Nevis in 2010?
Provide a short and direct response. -1.16. What is the difference between the Expenditure(as % of GDP) of Antigua and Barbuda in 2006 and the Expenditure(as % of GDP) of United States in 2010?
Your answer should be very brief. -12.74. What is the difference between the Expenditure(as % of GDP) in St. Kitts and Nevis in 2006 and the Expenditure(as % of GDP) in United States in 2010?
Give a very brief answer. -12.99. What is the difference between the Expenditure(as % of GDP) of East Asia (all income levels) in 2007 and the Expenditure(as % of GDP) of Antigua and Barbuda in 2008?
Your answer should be very brief. 1.59. What is the difference between the Expenditure(as % of GDP) in East Asia (all income levels) in 2007 and the Expenditure(as % of GDP) in St. Kitts and Nevis in 2008?
Provide a succinct answer. 2.13. What is the difference between the Expenditure(as % of GDP) of East Asia (all income levels) in 2007 and the Expenditure(as % of GDP) of United States in 2008?
Make the answer very short. -9.78. What is the difference between the Expenditure(as % of GDP) in Antigua and Barbuda in 2007 and the Expenditure(as % of GDP) in St. Kitts and Nevis in 2008?
Ensure brevity in your answer.  0.14. What is the difference between the Expenditure(as % of GDP) of Antigua and Barbuda in 2007 and the Expenditure(as % of GDP) of United States in 2008?
Make the answer very short. -11.76. What is the difference between the Expenditure(as % of GDP) of St. Kitts and Nevis in 2007 and the Expenditure(as % of GDP) of United States in 2008?
Your response must be concise. -12.04. What is the difference between the Expenditure(as % of GDP) in East Asia (all income levels) in 2007 and the Expenditure(as % of GDP) in Antigua and Barbuda in 2009?
Your response must be concise. 1.42. What is the difference between the Expenditure(as % of GDP) in East Asia (all income levels) in 2007 and the Expenditure(as % of GDP) in St. Kitts and Nevis in 2009?
Your response must be concise. 1.32. What is the difference between the Expenditure(as % of GDP) of East Asia (all income levels) in 2007 and the Expenditure(as % of GDP) of United States in 2009?
Keep it short and to the point. -10.74. What is the difference between the Expenditure(as % of GDP) in Antigua and Barbuda in 2007 and the Expenditure(as % of GDP) in St. Kitts and Nevis in 2009?
Make the answer very short. -0.67. What is the difference between the Expenditure(as % of GDP) of Antigua and Barbuda in 2007 and the Expenditure(as % of GDP) of United States in 2009?
Give a very brief answer. -12.73. What is the difference between the Expenditure(as % of GDP) of St. Kitts and Nevis in 2007 and the Expenditure(as % of GDP) of United States in 2009?
Your response must be concise. -13. What is the difference between the Expenditure(as % of GDP) in East Asia (all income levels) in 2007 and the Expenditure(as % of GDP) in Antigua and Barbuda in 2010?
Your answer should be compact. 0.69. What is the difference between the Expenditure(as % of GDP) in East Asia (all income levels) in 2007 and the Expenditure(as % of GDP) in St. Kitts and Nevis in 2010?
Provide a succinct answer. 0.82. What is the difference between the Expenditure(as % of GDP) in East Asia (all income levels) in 2007 and the Expenditure(as % of GDP) in United States in 2010?
Give a very brief answer. -10.76. What is the difference between the Expenditure(as % of GDP) in Antigua and Barbuda in 2007 and the Expenditure(as % of GDP) in St. Kitts and Nevis in 2010?
Keep it short and to the point. -1.16. What is the difference between the Expenditure(as % of GDP) of Antigua and Barbuda in 2007 and the Expenditure(as % of GDP) of United States in 2010?
Provide a succinct answer. -12.75. What is the difference between the Expenditure(as % of GDP) in St. Kitts and Nevis in 2007 and the Expenditure(as % of GDP) in United States in 2010?
Provide a short and direct response. -13.02. What is the difference between the Expenditure(as % of GDP) in East Asia (all income levels) in 2008 and the Expenditure(as % of GDP) in Antigua and Barbuda in 2009?
Offer a terse response. 1.6. What is the difference between the Expenditure(as % of GDP) in East Asia (all income levels) in 2008 and the Expenditure(as % of GDP) in St. Kitts and Nevis in 2009?
Give a very brief answer. 1.5. What is the difference between the Expenditure(as % of GDP) of East Asia (all income levels) in 2008 and the Expenditure(as % of GDP) of United States in 2009?
Ensure brevity in your answer.  -10.56. What is the difference between the Expenditure(as % of GDP) of Antigua and Barbuda in 2008 and the Expenditure(as % of GDP) of St. Kitts and Nevis in 2009?
Ensure brevity in your answer.  -0.27. What is the difference between the Expenditure(as % of GDP) of Antigua and Barbuda in 2008 and the Expenditure(as % of GDP) of United States in 2009?
Provide a short and direct response. -12.33. What is the difference between the Expenditure(as % of GDP) in St. Kitts and Nevis in 2008 and the Expenditure(as % of GDP) in United States in 2009?
Ensure brevity in your answer.  -12.87. What is the difference between the Expenditure(as % of GDP) in East Asia (all income levels) in 2008 and the Expenditure(as % of GDP) in Antigua and Barbuda in 2010?
Your answer should be very brief. 0.87. What is the difference between the Expenditure(as % of GDP) in East Asia (all income levels) in 2008 and the Expenditure(as % of GDP) in St. Kitts and Nevis in 2010?
Make the answer very short. 1.01. What is the difference between the Expenditure(as % of GDP) in East Asia (all income levels) in 2008 and the Expenditure(as % of GDP) in United States in 2010?
Your response must be concise. -10.58. What is the difference between the Expenditure(as % of GDP) of Antigua and Barbuda in 2008 and the Expenditure(as % of GDP) of St. Kitts and Nevis in 2010?
Offer a terse response. -0.77. What is the difference between the Expenditure(as % of GDP) of Antigua and Barbuda in 2008 and the Expenditure(as % of GDP) of United States in 2010?
Your answer should be very brief. -12.35. What is the difference between the Expenditure(as % of GDP) of St. Kitts and Nevis in 2008 and the Expenditure(as % of GDP) of United States in 2010?
Offer a very short reply. -12.89. What is the difference between the Expenditure(as % of GDP) in East Asia (all income levels) in 2009 and the Expenditure(as % of GDP) in Antigua and Barbuda in 2010?
Make the answer very short. 1.43. What is the difference between the Expenditure(as % of GDP) in East Asia (all income levels) in 2009 and the Expenditure(as % of GDP) in St. Kitts and Nevis in 2010?
Make the answer very short. 1.56. What is the difference between the Expenditure(as % of GDP) of East Asia (all income levels) in 2009 and the Expenditure(as % of GDP) of United States in 2010?
Your response must be concise. -10.02. What is the difference between the Expenditure(as % of GDP) in Antigua and Barbuda in 2009 and the Expenditure(as % of GDP) in St. Kitts and Nevis in 2010?
Keep it short and to the point. -0.6. What is the difference between the Expenditure(as % of GDP) in Antigua and Barbuda in 2009 and the Expenditure(as % of GDP) in United States in 2010?
Your answer should be very brief. -12.18. What is the difference between the Expenditure(as % of GDP) in St. Kitts and Nevis in 2009 and the Expenditure(as % of GDP) in United States in 2010?
Your response must be concise. -12.08. What is the average Expenditure(as % of GDP) of East Asia (all income levels) per year?
Your response must be concise. 6.66. What is the average Expenditure(as % of GDP) in Antigua and Barbuda per year?
Provide a succinct answer. 4.63. What is the average Expenditure(as % of GDP) of St. Kitts and Nevis per year?
Offer a very short reply. 4.21. What is the average Expenditure(as % of GDP) of United States per year?
Offer a terse response. 15.85. In the year 2003, what is the difference between the Expenditure(as % of GDP) in East Asia (all income levels) and Expenditure(as % of GDP) in Antigua and Barbuda?
Provide a succinct answer. 2.28. In the year 2003, what is the difference between the Expenditure(as % of GDP) in East Asia (all income levels) and Expenditure(as % of GDP) in St. Kitts and Nevis?
Keep it short and to the point. 2.97. In the year 2003, what is the difference between the Expenditure(as % of GDP) of East Asia (all income levels) and Expenditure(as % of GDP) of United States?
Your answer should be very brief. -8.46. In the year 2003, what is the difference between the Expenditure(as % of GDP) in Antigua and Barbuda and Expenditure(as % of GDP) in St. Kitts and Nevis?
Keep it short and to the point. 0.69. In the year 2003, what is the difference between the Expenditure(as % of GDP) of Antigua and Barbuda and Expenditure(as % of GDP) of United States?
Make the answer very short. -10.75. In the year 2003, what is the difference between the Expenditure(as % of GDP) of St. Kitts and Nevis and Expenditure(as % of GDP) of United States?
Provide a succinct answer. -11.43. In the year 2004, what is the difference between the Expenditure(as % of GDP) of East Asia (all income levels) and Expenditure(as % of GDP) of Antigua and Barbuda?
Your response must be concise. 2.39. In the year 2004, what is the difference between the Expenditure(as % of GDP) of East Asia (all income levels) and Expenditure(as % of GDP) of St. Kitts and Nevis?
Offer a very short reply. 3.12. In the year 2004, what is the difference between the Expenditure(as % of GDP) in East Asia (all income levels) and Expenditure(as % of GDP) in United States?
Provide a succinct answer. -8.56. In the year 2004, what is the difference between the Expenditure(as % of GDP) in Antigua and Barbuda and Expenditure(as % of GDP) in St. Kitts and Nevis?
Your answer should be very brief. 0.73. In the year 2004, what is the difference between the Expenditure(as % of GDP) of Antigua and Barbuda and Expenditure(as % of GDP) of United States?
Provide a succinct answer. -10.95. In the year 2004, what is the difference between the Expenditure(as % of GDP) of St. Kitts and Nevis and Expenditure(as % of GDP) of United States?
Ensure brevity in your answer.  -11.68. In the year 2005, what is the difference between the Expenditure(as % of GDP) in East Asia (all income levels) and Expenditure(as % of GDP) in Antigua and Barbuda?
Make the answer very short. 2.21. In the year 2005, what is the difference between the Expenditure(as % of GDP) of East Asia (all income levels) and Expenditure(as % of GDP) of St. Kitts and Nevis?
Make the answer very short. 3.1. In the year 2005, what is the difference between the Expenditure(as % of GDP) of East Asia (all income levels) and Expenditure(as % of GDP) of United States?
Keep it short and to the point. -8.57. In the year 2005, what is the difference between the Expenditure(as % of GDP) in Antigua and Barbuda and Expenditure(as % of GDP) in St. Kitts and Nevis?
Your answer should be compact. 0.89. In the year 2005, what is the difference between the Expenditure(as % of GDP) in Antigua and Barbuda and Expenditure(as % of GDP) in United States?
Your answer should be very brief. -10.78. In the year 2005, what is the difference between the Expenditure(as % of GDP) in St. Kitts and Nevis and Expenditure(as % of GDP) in United States?
Your answer should be compact. -11.67. In the year 2006, what is the difference between the Expenditure(as % of GDP) of East Asia (all income levels) and Expenditure(as % of GDP) of Antigua and Barbuda?
Your response must be concise. 2.17. In the year 2006, what is the difference between the Expenditure(as % of GDP) of East Asia (all income levels) and Expenditure(as % of GDP) of St. Kitts and Nevis?
Give a very brief answer. 2.42. In the year 2006, what is the difference between the Expenditure(as % of GDP) of East Asia (all income levels) and Expenditure(as % of GDP) of United States?
Give a very brief answer. -8.83. In the year 2006, what is the difference between the Expenditure(as % of GDP) in Antigua and Barbuda and Expenditure(as % of GDP) in St. Kitts and Nevis?
Your answer should be compact. 0.25. In the year 2006, what is the difference between the Expenditure(as % of GDP) in Antigua and Barbuda and Expenditure(as % of GDP) in United States?
Offer a terse response. -11. In the year 2006, what is the difference between the Expenditure(as % of GDP) of St. Kitts and Nevis and Expenditure(as % of GDP) of United States?
Provide a succinct answer. -11.25. In the year 2007, what is the difference between the Expenditure(as % of GDP) in East Asia (all income levels) and Expenditure(as % of GDP) in Antigua and Barbuda?
Provide a succinct answer. 1.99. In the year 2007, what is the difference between the Expenditure(as % of GDP) in East Asia (all income levels) and Expenditure(as % of GDP) in St. Kitts and Nevis?
Offer a very short reply. 2.26. In the year 2007, what is the difference between the Expenditure(as % of GDP) in East Asia (all income levels) and Expenditure(as % of GDP) in United States?
Keep it short and to the point. -9.29. In the year 2007, what is the difference between the Expenditure(as % of GDP) of Antigua and Barbuda and Expenditure(as % of GDP) of St. Kitts and Nevis?
Ensure brevity in your answer.  0.27. In the year 2007, what is the difference between the Expenditure(as % of GDP) of Antigua and Barbuda and Expenditure(as % of GDP) of United States?
Ensure brevity in your answer.  -11.28. In the year 2007, what is the difference between the Expenditure(as % of GDP) of St. Kitts and Nevis and Expenditure(as % of GDP) of United States?
Make the answer very short. -11.55. In the year 2008, what is the difference between the Expenditure(as % of GDP) of East Asia (all income levels) and Expenditure(as % of GDP) of Antigua and Barbuda?
Your response must be concise. 1.77. In the year 2008, what is the difference between the Expenditure(as % of GDP) of East Asia (all income levels) and Expenditure(as % of GDP) of St. Kitts and Nevis?
Make the answer very short. 2.31. In the year 2008, what is the difference between the Expenditure(as % of GDP) in East Asia (all income levels) and Expenditure(as % of GDP) in United States?
Ensure brevity in your answer.  -9.6. In the year 2008, what is the difference between the Expenditure(as % of GDP) in Antigua and Barbuda and Expenditure(as % of GDP) in St. Kitts and Nevis?
Make the answer very short. 0.54. In the year 2008, what is the difference between the Expenditure(as % of GDP) of Antigua and Barbuda and Expenditure(as % of GDP) of United States?
Provide a succinct answer. -11.37. In the year 2008, what is the difference between the Expenditure(as % of GDP) of St. Kitts and Nevis and Expenditure(as % of GDP) of United States?
Make the answer very short. -11.9. In the year 2009, what is the difference between the Expenditure(as % of GDP) in East Asia (all income levels) and Expenditure(as % of GDP) in Antigua and Barbuda?
Your answer should be compact. 2.16. In the year 2009, what is the difference between the Expenditure(as % of GDP) of East Asia (all income levels) and Expenditure(as % of GDP) of St. Kitts and Nevis?
Your answer should be compact. 2.06. In the year 2009, what is the difference between the Expenditure(as % of GDP) in East Asia (all income levels) and Expenditure(as % of GDP) in United States?
Offer a terse response. -10. In the year 2009, what is the difference between the Expenditure(as % of GDP) of Antigua and Barbuda and Expenditure(as % of GDP) of St. Kitts and Nevis?
Offer a very short reply. -0.1. In the year 2009, what is the difference between the Expenditure(as % of GDP) in Antigua and Barbuda and Expenditure(as % of GDP) in United States?
Your answer should be compact. -12.17. In the year 2009, what is the difference between the Expenditure(as % of GDP) of St. Kitts and Nevis and Expenditure(as % of GDP) of United States?
Ensure brevity in your answer.  -12.06. In the year 2010, what is the difference between the Expenditure(as % of GDP) of East Asia (all income levels) and Expenditure(as % of GDP) of Antigua and Barbuda?
Give a very brief answer. 1.28. In the year 2010, what is the difference between the Expenditure(as % of GDP) in East Asia (all income levels) and Expenditure(as % of GDP) in St. Kitts and Nevis?
Your answer should be compact. 1.42. In the year 2010, what is the difference between the Expenditure(as % of GDP) of East Asia (all income levels) and Expenditure(as % of GDP) of United States?
Ensure brevity in your answer.  -10.17. In the year 2010, what is the difference between the Expenditure(as % of GDP) in Antigua and Barbuda and Expenditure(as % of GDP) in St. Kitts and Nevis?
Offer a very short reply. 0.14. In the year 2010, what is the difference between the Expenditure(as % of GDP) of Antigua and Barbuda and Expenditure(as % of GDP) of United States?
Make the answer very short. -11.45. In the year 2010, what is the difference between the Expenditure(as % of GDP) in St. Kitts and Nevis and Expenditure(as % of GDP) in United States?
Your answer should be very brief. -11.58. What is the ratio of the Expenditure(as % of GDP) of Antigua and Barbuda in 2003 to that in 2004?
Provide a short and direct response. 1.03. What is the ratio of the Expenditure(as % of GDP) in St. Kitts and Nevis in 2003 to that in 2004?
Make the answer very short. 1.05. What is the ratio of the Expenditure(as % of GDP) of United States in 2003 to that in 2004?
Keep it short and to the point. 1. What is the ratio of the Expenditure(as % of GDP) in East Asia (all income levels) in 2003 to that in 2005?
Keep it short and to the point. 1. What is the ratio of the Expenditure(as % of GDP) of Antigua and Barbuda in 2003 to that in 2005?
Provide a short and direct response. 0.99. What is the ratio of the Expenditure(as % of GDP) in St. Kitts and Nevis in 2003 to that in 2005?
Keep it short and to the point. 1.04. What is the ratio of the Expenditure(as % of GDP) of United States in 2003 to that in 2005?
Your answer should be very brief. 0.99. What is the ratio of the Expenditure(as % of GDP) in East Asia (all income levels) in 2003 to that in 2006?
Your answer should be compact. 1.03. What is the ratio of the Expenditure(as % of GDP) in Antigua and Barbuda in 2003 to that in 2006?
Your answer should be very brief. 1.01. What is the ratio of the Expenditure(as % of GDP) in St. Kitts and Nevis in 2003 to that in 2006?
Provide a succinct answer. 0.91. What is the ratio of the Expenditure(as % of GDP) of United States in 2003 to that in 2006?
Offer a terse response. 0.99. What is the ratio of the Expenditure(as % of GDP) of East Asia (all income levels) in 2003 to that in 2007?
Keep it short and to the point. 1.06. What is the ratio of the Expenditure(as % of GDP) in Antigua and Barbuda in 2003 to that in 2007?
Provide a succinct answer. 1.01. What is the ratio of the Expenditure(as % of GDP) of St. Kitts and Nevis in 2003 to that in 2007?
Offer a very short reply. 0.91. What is the ratio of the Expenditure(as % of GDP) of United States in 2003 to that in 2007?
Your response must be concise. 0.97. What is the ratio of the Expenditure(as % of GDP) of East Asia (all income levels) in 2003 to that in 2008?
Give a very brief answer. 1.03. What is the ratio of the Expenditure(as % of GDP) in Antigua and Barbuda in 2003 to that in 2008?
Provide a short and direct response. 0.93. What is the ratio of the Expenditure(as % of GDP) in St. Kitts and Nevis in 2003 to that in 2008?
Provide a short and direct response. 0.88. What is the ratio of the Expenditure(as % of GDP) of United States in 2003 to that in 2008?
Ensure brevity in your answer.  0.94. What is the ratio of the Expenditure(as % of GDP) of East Asia (all income levels) in 2003 to that in 2009?
Your response must be concise. 0.95. What is the ratio of the Expenditure(as % of GDP) of Antigua and Barbuda in 2003 to that in 2009?
Your answer should be very brief. 0.9. What is the ratio of the Expenditure(as % of GDP) in St. Kitts and Nevis in 2003 to that in 2009?
Provide a short and direct response. 0.74. What is the ratio of the Expenditure(as % of GDP) in United States in 2003 to that in 2009?
Provide a succinct answer. 0.89. What is the ratio of the Expenditure(as % of GDP) of Antigua and Barbuda in 2003 to that in 2010?
Ensure brevity in your answer.  0.78. What is the ratio of the Expenditure(as % of GDP) in St. Kitts and Nevis in 2003 to that in 2010?
Your response must be concise. 0.67. What is the ratio of the Expenditure(as % of GDP) of United States in 2003 to that in 2010?
Give a very brief answer. 0.89. What is the ratio of the Expenditure(as % of GDP) of East Asia (all income levels) in 2004 to that in 2005?
Your answer should be very brief. 1. What is the ratio of the Expenditure(as % of GDP) in Antigua and Barbuda in 2004 to that in 2005?
Ensure brevity in your answer.  0.96. What is the ratio of the Expenditure(as % of GDP) in St. Kitts and Nevis in 2004 to that in 2005?
Give a very brief answer. 0.99. What is the ratio of the Expenditure(as % of GDP) in United States in 2004 to that in 2005?
Your answer should be compact. 1. What is the ratio of the Expenditure(as % of GDP) of East Asia (all income levels) in 2004 to that in 2006?
Offer a very short reply. 1.02. What is the ratio of the Expenditure(as % of GDP) in Antigua and Barbuda in 2004 to that in 2006?
Your answer should be compact. 0.98. What is the ratio of the Expenditure(as % of GDP) in St. Kitts and Nevis in 2004 to that in 2006?
Provide a succinct answer. 0.86. What is the ratio of the Expenditure(as % of GDP) in East Asia (all income levels) in 2004 to that in 2007?
Your answer should be compact. 1.05. What is the ratio of the Expenditure(as % of GDP) of Antigua and Barbuda in 2004 to that in 2007?
Offer a terse response. 0.98. What is the ratio of the Expenditure(as % of GDP) of St. Kitts and Nevis in 2004 to that in 2007?
Your answer should be compact. 0.87. What is the ratio of the Expenditure(as % of GDP) of United States in 2004 to that in 2007?
Provide a succinct answer. 0.97. What is the ratio of the Expenditure(as % of GDP) of East Asia (all income levels) in 2004 to that in 2008?
Give a very brief answer. 1.02. What is the ratio of the Expenditure(as % of GDP) in Antigua and Barbuda in 2004 to that in 2008?
Keep it short and to the point. 0.9. What is the ratio of the Expenditure(as % of GDP) of St. Kitts and Nevis in 2004 to that in 2008?
Provide a short and direct response. 0.84. What is the ratio of the Expenditure(as % of GDP) of United States in 2004 to that in 2008?
Provide a short and direct response. 0.94. What is the ratio of the Expenditure(as % of GDP) in East Asia (all income levels) in 2004 to that in 2009?
Your response must be concise. 0.94. What is the ratio of the Expenditure(as % of GDP) in Antigua and Barbuda in 2004 to that in 2009?
Offer a very short reply. 0.87. What is the ratio of the Expenditure(as % of GDP) of St. Kitts and Nevis in 2004 to that in 2009?
Ensure brevity in your answer.  0.71. What is the ratio of the Expenditure(as % of GDP) of United States in 2004 to that in 2009?
Keep it short and to the point. 0.89. What is the ratio of the Expenditure(as % of GDP) of East Asia (all income levels) in 2004 to that in 2010?
Give a very brief answer. 0.96. What is the ratio of the Expenditure(as % of GDP) in Antigua and Barbuda in 2004 to that in 2010?
Your answer should be compact. 0.76. What is the ratio of the Expenditure(as % of GDP) of St. Kitts and Nevis in 2004 to that in 2010?
Offer a terse response. 0.64. What is the ratio of the Expenditure(as % of GDP) in United States in 2004 to that in 2010?
Offer a very short reply. 0.89. What is the ratio of the Expenditure(as % of GDP) of East Asia (all income levels) in 2005 to that in 2006?
Your response must be concise. 1.02. What is the ratio of the Expenditure(as % of GDP) in Antigua and Barbuda in 2005 to that in 2006?
Provide a short and direct response. 1.03. What is the ratio of the Expenditure(as % of GDP) of St. Kitts and Nevis in 2005 to that in 2006?
Your answer should be compact. 0.87. What is the ratio of the Expenditure(as % of GDP) in East Asia (all income levels) in 2005 to that in 2007?
Offer a terse response. 1.05. What is the ratio of the Expenditure(as % of GDP) of Antigua and Barbuda in 2005 to that in 2007?
Your response must be concise. 1.03. What is the ratio of the Expenditure(as % of GDP) of St. Kitts and Nevis in 2005 to that in 2007?
Offer a very short reply. 0.88. What is the ratio of the Expenditure(as % of GDP) in United States in 2005 to that in 2007?
Ensure brevity in your answer.  0.98. What is the ratio of the Expenditure(as % of GDP) of East Asia (all income levels) in 2005 to that in 2008?
Keep it short and to the point. 1.02. What is the ratio of the Expenditure(as % of GDP) of Antigua and Barbuda in 2005 to that in 2008?
Offer a terse response. 0.94. What is the ratio of the Expenditure(as % of GDP) of St. Kitts and Nevis in 2005 to that in 2008?
Keep it short and to the point. 0.85. What is the ratio of the Expenditure(as % of GDP) in United States in 2005 to that in 2008?
Your answer should be very brief. 0.95. What is the ratio of the Expenditure(as % of GDP) of East Asia (all income levels) in 2005 to that in 2009?
Offer a very short reply. 0.94. What is the ratio of the Expenditure(as % of GDP) of Antigua and Barbuda in 2005 to that in 2009?
Offer a very short reply. 0.91. What is the ratio of the Expenditure(as % of GDP) in St. Kitts and Nevis in 2005 to that in 2009?
Provide a succinct answer. 0.71. What is the ratio of the Expenditure(as % of GDP) of United States in 2005 to that in 2009?
Provide a succinct answer. 0.89. What is the ratio of the Expenditure(as % of GDP) of East Asia (all income levels) in 2005 to that in 2010?
Offer a terse response. 0.96. What is the ratio of the Expenditure(as % of GDP) in Antigua and Barbuda in 2005 to that in 2010?
Keep it short and to the point. 0.79. What is the ratio of the Expenditure(as % of GDP) of St. Kitts and Nevis in 2005 to that in 2010?
Provide a short and direct response. 0.65. What is the ratio of the Expenditure(as % of GDP) of United States in 2005 to that in 2010?
Ensure brevity in your answer.  0.89. What is the ratio of the Expenditure(as % of GDP) in East Asia (all income levels) in 2006 to that in 2007?
Your response must be concise. 1.03. What is the ratio of the Expenditure(as % of GDP) in Antigua and Barbuda in 2006 to that in 2007?
Ensure brevity in your answer.  1. What is the ratio of the Expenditure(as % of GDP) in St. Kitts and Nevis in 2006 to that in 2007?
Provide a short and direct response. 1.01. What is the ratio of the Expenditure(as % of GDP) of United States in 2006 to that in 2007?
Your response must be concise. 0.98. What is the ratio of the Expenditure(as % of GDP) of East Asia (all income levels) in 2006 to that in 2008?
Give a very brief answer. 1. What is the ratio of the Expenditure(as % of GDP) in Antigua and Barbuda in 2006 to that in 2008?
Provide a succinct answer. 0.92. What is the ratio of the Expenditure(as % of GDP) of St. Kitts and Nevis in 2006 to that in 2008?
Your answer should be compact. 0.97. What is the ratio of the Expenditure(as % of GDP) in United States in 2006 to that in 2008?
Provide a succinct answer. 0.95. What is the ratio of the Expenditure(as % of GDP) of East Asia (all income levels) in 2006 to that in 2009?
Provide a succinct answer. 0.92. What is the ratio of the Expenditure(as % of GDP) in Antigua and Barbuda in 2006 to that in 2009?
Make the answer very short. 0.89. What is the ratio of the Expenditure(as % of GDP) of St. Kitts and Nevis in 2006 to that in 2009?
Ensure brevity in your answer.  0.82. What is the ratio of the Expenditure(as % of GDP) of United States in 2006 to that in 2009?
Keep it short and to the point. 0.9. What is the ratio of the Expenditure(as % of GDP) of East Asia (all income levels) in 2006 to that in 2010?
Your response must be concise. 0.94. What is the ratio of the Expenditure(as % of GDP) in Antigua and Barbuda in 2006 to that in 2010?
Make the answer very short. 0.77. What is the ratio of the Expenditure(as % of GDP) in St. Kitts and Nevis in 2006 to that in 2010?
Provide a succinct answer. 0.74. What is the ratio of the Expenditure(as % of GDP) in United States in 2006 to that in 2010?
Your response must be concise. 0.9. What is the ratio of the Expenditure(as % of GDP) of East Asia (all income levels) in 2007 to that in 2008?
Give a very brief answer. 0.97. What is the ratio of the Expenditure(as % of GDP) of Antigua and Barbuda in 2007 to that in 2008?
Provide a succinct answer. 0.92. What is the ratio of the Expenditure(as % of GDP) of St. Kitts and Nevis in 2007 to that in 2008?
Your answer should be compact. 0.97. What is the ratio of the Expenditure(as % of GDP) in United States in 2007 to that in 2008?
Give a very brief answer. 0.97. What is the ratio of the Expenditure(as % of GDP) of East Asia (all income levels) in 2007 to that in 2009?
Offer a terse response. 0.9. What is the ratio of the Expenditure(as % of GDP) of Antigua and Barbuda in 2007 to that in 2009?
Provide a succinct answer. 0.88. What is the ratio of the Expenditure(as % of GDP) in St. Kitts and Nevis in 2007 to that in 2009?
Offer a very short reply. 0.81. What is the ratio of the Expenditure(as % of GDP) of United States in 2007 to that in 2009?
Offer a terse response. 0.92. What is the ratio of the Expenditure(as % of GDP) of East Asia (all income levels) in 2007 to that in 2010?
Offer a very short reply. 0.91. What is the ratio of the Expenditure(as % of GDP) of Antigua and Barbuda in 2007 to that in 2010?
Keep it short and to the point. 0.77. What is the ratio of the Expenditure(as % of GDP) in St. Kitts and Nevis in 2007 to that in 2010?
Make the answer very short. 0.74. What is the ratio of the Expenditure(as % of GDP) of United States in 2007 to that in 2010?
Ensure brevity in your answer.  0.91. What is the ratio of the Expenditure(as % of GDP) of East Asia (all income levels) in 2008 to that in 2009?
Give a very brief answer. 0.92. What is the ratio of the Expenditure(as % of GDP) in Antigua and Barbuda in 2008 to that in 2009?
Make the answer very short. 0.97. What is the ratio of the Expenditure(as % of GDP) in St. Kitts and Nevis in 2008 to that in 2009?
Your answer should be compact. 0.84. What is the ratio of the Expenditure(as % of GDP) in United States in 2008 to that in 2009?
Your answer should be very brief. 0.94. What is the ratio of the Expenditure(as % of GDP) of East Asia (all income levels) in 2008 to that in 2010?
Give a very brief answer. 0.94. What is the ratio of the Expenditure(as % of GDP) of Antigua and Barbuda in 2008 to that in 2010?
Offer a terse response. 0.84. What is the ratio of the Expenditure(as % of GDP) in St. Kitts and Nevis in 2008 to that in 2010?
Your answer should be very brief. 0.76. What is the ratio of the Expenditure(as % of GDP) in United States in 2008 to that in 2010?
Provide a succinct answer. 0.94. What is the ratio of the Expenditure(as % of GDP) in East Asia (all income levels) in 2009 to that in 2010?
Offer a terse response. 1.02. What is the ratio of the Expenditure(as % of GDP) of Antigua and Barbuda in 2009 to that in 2010?
Provide a succinct answer. 0.87. What is the ratio of the Expenditure(as % of GDP) of St. Kitts and Nevis in 2009 to that in 2010?
Provide a short and direct response. 0.91. What is the difference between the highest and the second highest Expenditure(as % of GDP) of East Asia (all income levels)?
Offer a terse response. 0.15. What is the difference between the highest and the second highest Expenditure(as % of GDP) in Antigua and Barbuda?
Offer a very short reply. 0.74. What is the difference between the highest and the second highest Expenditure(as % of GDP) in St. Kitts and Nevis?
Your response must be concise. 0.5. What is the difference between the highest and the second highest Expenditure(as % of GDP) in United States?
Provide a succinct answer. 0.02. What is the difference between the highest and the lowest Expenditure(as % of GDP) in East Asia (all income levels)?
Keep it short and to the point. 0.74. What is the difference between the highest and the lowest Expenditure(as % of GDP) of Antigua and Barbuda?
Offer a terse response. 1.38. What is the difference between the highest and the lowest Expenditure(as % of GDP) of St. Kitts and Nevis?
Your answer should be very brief. 1.97. What is the difference between the highest and the lowest Expenditure(as % of GDP) in United States?
Offer a terse response. 1.94. 